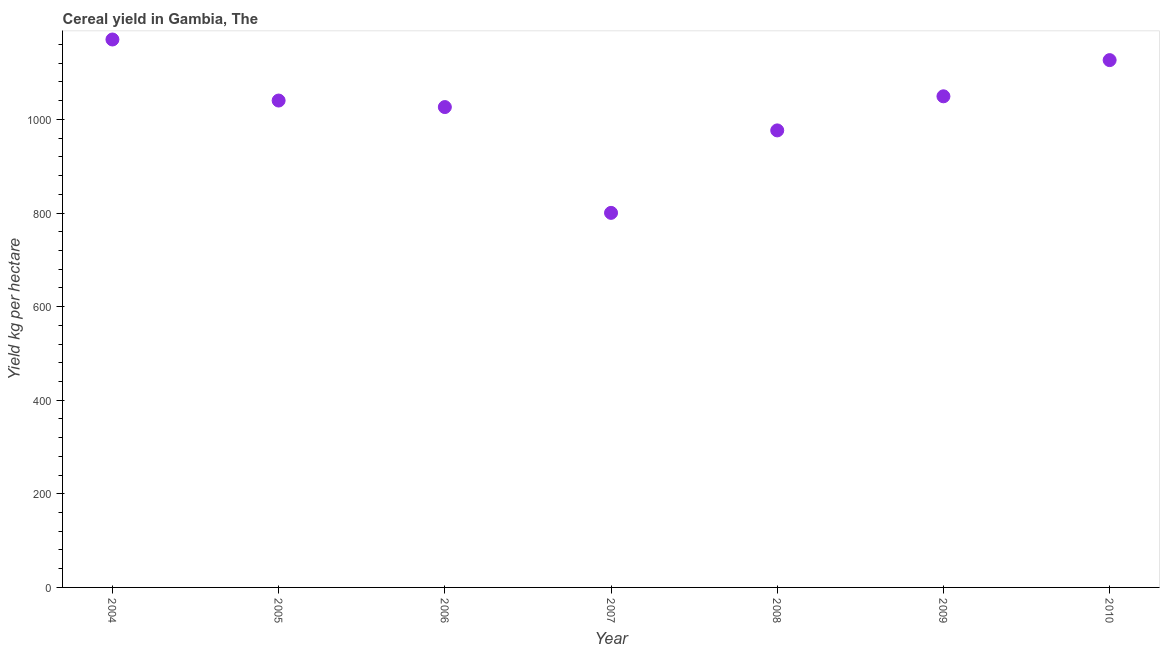What is the cereal yield in 2007?
Offer a very short reply. 800.31. Across all years, what is the maximum cereal yield?
Provide a succinct answer. 1170.76. Across all years, what is the minimum cereal yield?
Your response must be concise. 800.31. In which year was the cereal yield maximum?
Give a very brief answer. 2004. What is the sum of the cereal yield?
Give a very brief answer. 7190.33. What is the difference between the cereal yield in 2007 and 2008?
Offer a terse response. -176.2. What is the average cereal yield per year?
Your answer should be compact. 1027.19. What is the median cereal yield?
Make the answer very short. 1040.31. In how many years, is the cereal yield greater than 760 kg per hectare?
Your response must be concise. 7. Do a majority of the years between 2009 and 2010 (inclusive) have cereal yield greater than 960 kg per hectare?
Make the answer very short. Yes. What is the ratio of the cereal yield in 2004 to that in 2006?
Keep it short and to the point. 1.14. What is the difference between the highest and the second highest cereal yield?
Provide a short and direct response. 44.06. Is the sum of the cereal yield in 2006 and 2007 greater than the maximum cereal yield across all years?
Ensure brevity in your answer.  Yes. What is the difference between the highest and the lowest cereal yield?
Your answer should be very brief. 370.45. Does the cereal yield monotonically increase over the years?
Ensure brevity in your answer.  No. How many years are there in the graph?
Your answer should be compact. 7. What is the difference between two consecutive major ticks on the Y-axis?
Provide a short and direct response. 200. Does the graph contain any zero values?
Your answer should be very brief. No. What is the title of the graph?
Ensure brevity in your answer.  Cereal yield in Gambia, The. What is the label or title of the X-axis?
Provide a succinct answer. Year. What is the label or title of the Y-axis?
Give a very brief answer. Yield kg per hectare. What is the Yield kg per hectare in 2004?
Give a very brief answer. 1170.76. What is the Yield kg per hectare in 2005?
Offer a terse response. 1040.31. What is the Yield kg per hectare in 2006?
Make the answer very short. 1026.38. What is the Yield kg per hectare in 2007?
Provide a short and direct response. 800.31. What is the Yield kg per hectare in 2008?
Your answer should be very brief. 976.51. What is the Yield kg per hectare in 2009?
Provide a short and direct response. 1049.37. What is the Yield kg per hectare in 2010?
Keep it short and to the point. 1126.69. What is the difference between the Yield kg per hectare in 2004 and 2005?
Provide a succinct answer. 130.45. What is the difference between the Yield kg per hectare in 2004 and 2006?
Offer a very short reply. 144.38. What is the difference between the Yield kg per hectare in 2004 and 2007?
Ensure brevity in your answer.  370.45. What is the difference between the Yield kg per hectare in 2004 and 2008?
Offer a very short reply. 194.24. What is the difference between the Yield kg per hectare in 2004 and 2009?
Offer a very short reply. 121.38. What is the difference between the Yield kg per hectare in 2004 and 2010?
Offer a very short reply. 44.06. What is the difference between the Yield kg per hectare in 2005 and 2006?
Provide a succinct answer. 13.93. What is the difference between the Yield kg per hectare in 2005 and 2007?
Make the answer very short. 240. What is the difference between the Yield kg per hectare in 2005 and 2008?
Your response must be concise. 63.79. What is the difference between the Yield kg per hectare in 2005 and 2009?
Your answer should be compact. -9.07. What is the difference between the Yield kg per hectare in 2005 and 2010?
Provide a succinct answer. -86.39. What is the difference between the Yield kg per hectare in 2006 and 2007?
Give a very brief answer. 226.07. What is the difference between the Yield kg per hectare in 2006 and 2008?
Ensure brevity in your answer.  49.86. What is the difference between the Yield kg per hectare in 2006 and 2009?
Your response must be concise. -23. What is the difference between the Yield kg per hectare in 2006 and 2010?
Ensure brevity in your answer.  -100.32. What is the difference between the Yield kg per hectare in 2007 and 2008?
Make the answer very short. -176.2. What is the difference between the Yield kg per hectare in 2007 and 2009?
Offer a terse response. -249.06. What is the difference between the Yield kg per hectare in 2007 and 2010?
Offer a terse response. -326.38. What is the difference between the Yield kg per hectare in 2008 and 2009?
Your answer should be very brief. -72.86. What is the difference between the Yield kg per hectare in 2008 and 2010?
Provide a short and direct response. -150.18. What is the difference between the Yield kg per hectare in 2009 and 2010?
Your answer should be very brief. -77.32. What is the ratio of the Yield kg per hectare in 2004 to that in 2005?
Your response must be concise. 1.12. What is the ratio of the Yield kg per hectare in 2004 to that in 2006?
Give a very brief answer. 1.14. What is the ratio of the Yield kg per hectare in 2004 to that in 2007?
Give a very brief answer. 1.46. What is the ratio of the Yield kg per hectare in 2004 to that in 2008?
Your answer should be compact. 1.2. What is the ratio of the Yield kg per hectare in 2004 to that in 2009?
Offer a very short reply. 1.12. What is the ratio of the Yield kg per hectare in 2004 to that in 2010?
Your answer should be compact. 1.04. What is the ratio of the Yield kg per hectare in 2005 to that in 2007?
Your response must be concise. 1.3. What is the ratio of the Yield kg per hectare in 2005 to that in 2008?
Offer a terse response. 1.06. What is the ratio of the Yield kg per hectare in 2005 to that in 2009?
Make the answer very short. 0.99. What is the ratio of the Yield kg per hectare in 2005 to that in 2010?
Your answer should be very brief. 0.92. What is the ratio of the Yield kg per hectare in 2006 to that in 2007?
Your response must be concise. 1.28. What is the ratio of the Yield kg per hectare in 2006 to that in 2008?
Make the answer very short. 1.05. What is the ratio of the Yield kg per hectare in 2006 to that in 2009?
Offer a terse response. 0.98. What is the ratio of the Yield kg per hectare in 2006 to that in 2010?
Make the answer very short. 0.91. What is the ratio of the Yield kg per hectare in 2007 to that in 2008?
Your response must be concise. 0.82. What is the ratio of the Yield kg per hectare in 2007 to that in 2009?
Provide a succinct answer. 0.76. What is the ratio of the Yield kg per hectare in 2007 to that in 2010?
Make the answer very short. 0.71. What is the ratio of the Yield kg per hectare in 2008 to that in 2009?
Offer a terse response. 0.93. What is the ratio of the Yield kg per hectare in 2008 to that in 2010?
Provide a succinct answer. 0.87. What is the ratio of the Yield kg per hectare in 2009 to that in 2010?
Provide a short and direct response. 0.93. 